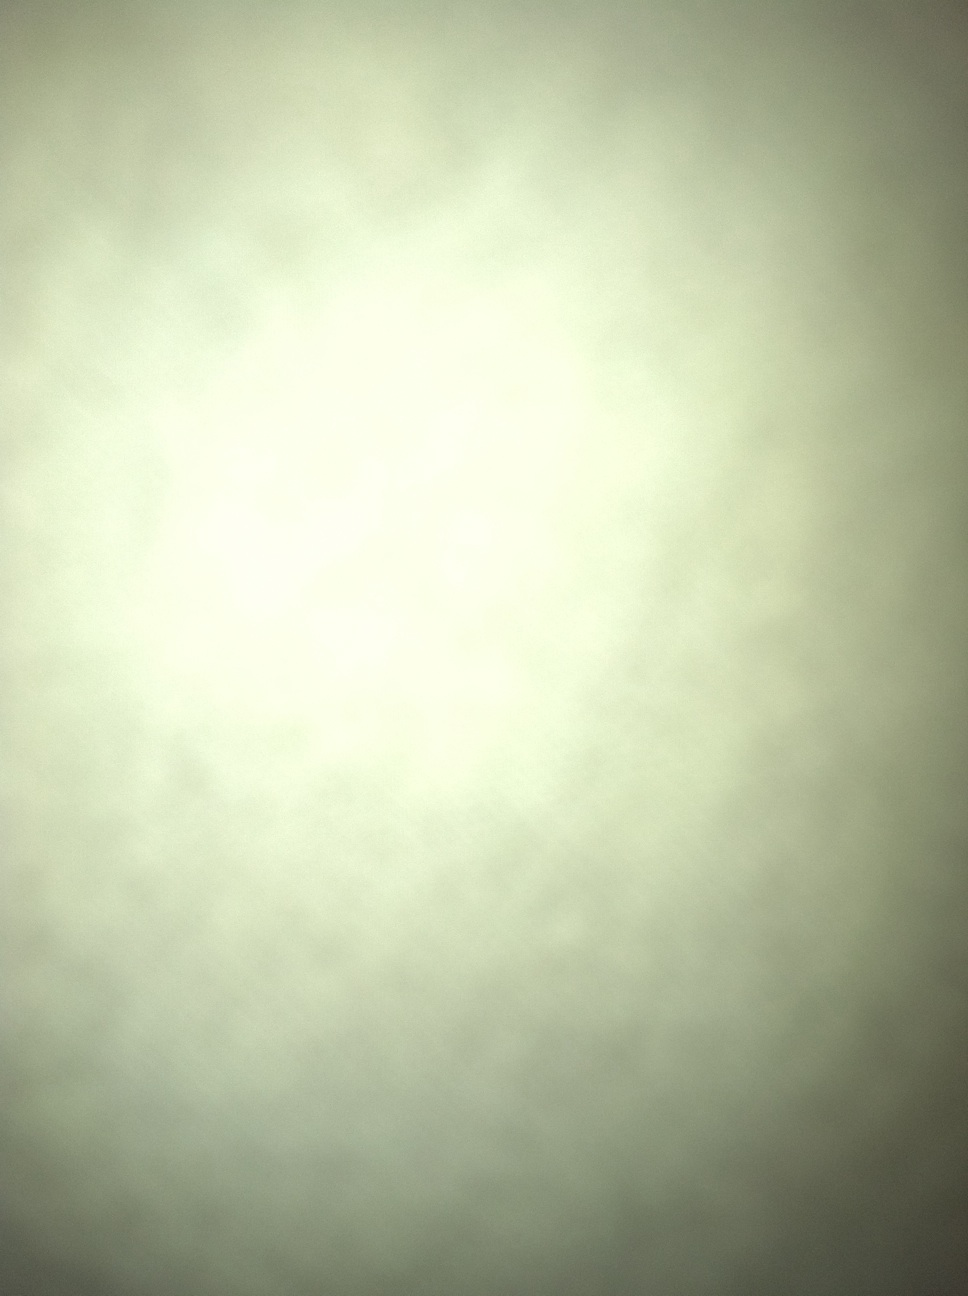Is there anything identifiable at all in this image? Upon close examination, the image doesn't reveal any identifiable objects or patterns. It's primarily a blend of faint light and shadow without distinct shapes. 